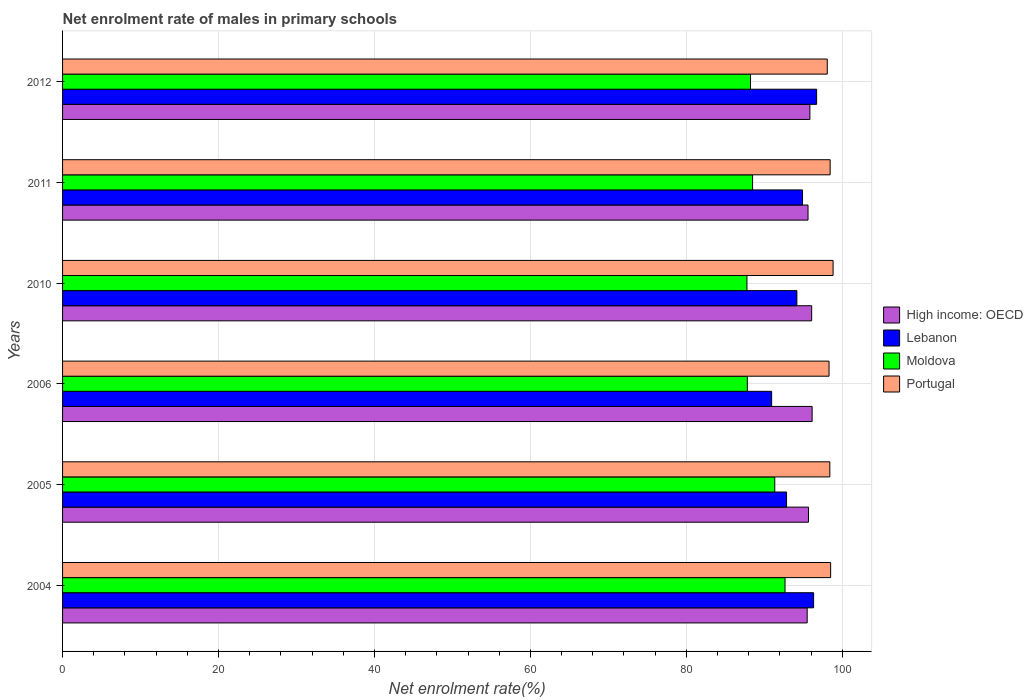How many different coloured bars are there?
Keep it short and to the point. 4. How many groups of bars are there?
Your answer should be very brief. 6. Are the number of bars per tick equal to the number of legend labels?
Provide a succinct answer. Yes. How many bars are there on the 2nd tick from the top?
Keep it short and to the point. 4. How many bars are there on the 5th tick from the bottom?
Your answer should be very brief. 4. What is the label of the 5th group of bars from the top?
Your answer should be compact. 2005. In how many cases, is the number of bars for a given year not equal to the number of legend labels?
Offer a terse response. 0. What is the net enrolment rate of males in primary schools in Moldova in 2012?
Offer a terse response. 88.23. Across all years, what is the maximum net enrolment rate of males in primary schools in High income: OECD?
Make the answer very short. 96.13. Across all years, what is the minimum net enrolment rate of males in primary schools in High income: OECD?
Your answer should be very brief. 95.5. In which year was the net enrolment rate of males in primary schools in Portugal maximum?
Keep it short and to the point. 2010. In which year was the net enrolment rate of males in primary schools in Portugal minimum?
Provide a short and direct response. 2012. What is the total net enrolment rate of males in primary schools in Lebanon in the graph?
Your answer should be very brief. 565.9. What is the difference between the net enrolment rate of males in primary schools in Lebanon in 2006 and that in 2010?
Your answer should be compact. -3.24. What is the difference between the net enrolment rate of males in primary schools in Portugal in 2004 and the net enrolment rate of males in primary schools in High income: OECD in 2005?
Keep it short and to the point. 2.84. What is the average net enrolment rate of males in primary schools in Lebanon per year?
Keep it short and to the point. 94.32. In the year 2005, what is the difference between the net enrolment rate of males in primary schools in Lebanon and net enrolment rate of males in primary schools in High income: OECD?
Make the answer very short. -2.81. What is the ratio of the net enrolment rate of males in primary schools in Moldova in 2004 to that in 2006?
Keep it short and to the point. 1.06. Is the difference between the net enrolment rate of males in primary schools in Lebanon in 2006 and 2011 greater than the difference between the net enrolment rate of males in primary schools in High income: OECD in 2006 and 2011?
Provide a succinct answer. No. What is the difference between the highest and the second highest net enrolment rate of males in primary schools in High income: OECD?
Ensure brevity in your answer.  0.06. What is the difference between the highest and the lowest net enrolment rate of males in primary schools in Lebanon?
Keep it short and to the point. 5.77. What does the 2nd bar from the bottom in 2006 represents?
Your response must be concise. Lebanon. Is it the case that in every year, the sum of the net enrolment rate of males in primary schools in Portugal and net enrolment rate of males in primary schools in Moldova is greater than the net enrolment rate of males in primary schools in High income: OECD?
Ensure brevity in your answer.  Yes. What is the difference between two consecutive major ticks on the X-axis?
Provide a succinct answer. 20. Where does the legend appear in the graph?
Your answer should be very brief. Center right. How many legend labels are there?
Keep it short and to the point. 4. What is the title of the graph?
Provide a short and direct response. Net enrolment rate of males in primary schools. What is the label or title of the X-axis?
Ensure brevity in your answer.  Net enrolment rate(%). What is the Net enrolment rate(%) in High income: OECD in 2004?
Offer a very short reply. 95.5. What is the Net enrolment rate(%) of Lebanon in 2004?
Your answer should be very brief. 96.32. What is the Net enrolment rate(%) of Moldova in 2004?
Keep it short and to the point. 92.66. What is the Net enrolment rate(%) of Portugal in 2004?
Provide a short and direct response. 98.51. What is the Net enrolment rate(%) in High income: OECD in 2005?
Your answer should be very brief. 95.67. What is the Net enrolment rate(%) of Lebanon in 2005?
Offer a very short reply. 92.85. What is the Net enrolment rate(%) in Moldova in 2005?
Provide a succinct answer. 91.34. What is the Net enrolment rate(%) of Portugal in 2005?
Your answer should be very brief. 98.4. What is the Net enrolment rate(%) in High income: OECD in 2006?
Keep it short and to the point. 96.13. What is the Net enrolment rate(%) in Lebanon in 2006?
Provide a short and direct response. 90.94. What is the Net enrolment rate(%) of Moldova in 2006?
Your answer should be compact. 87.82. What is the Net enrolment rate(%) of Portugal in 2006?
Make the answer very short. 98.3. What is the Net enrolment rate(%) of High income: OECD in 2010?
Keep it short and to the point. 96.08. What is the Net enrolment rate(%) of Lebanon in 2010?
Offer a terse response. 94.18. What is the Net enrolment rate(%) of Moldova in 2010?
Ensure brevity in your answer.  87.77. What is the Net enrolment rate(%) in Portugal in 2010?
Your answer should be compact. 98.82. What is the Net enrolment rate(%) of High income: OECD in 2011?
Offer a very short reply. 95.61. What is the Net enrolment rate(%) of Lebanon in 2011?
Make the answer very short. 94.9. What is the Net enrolment rate(%) of Moldova in 2011?
Your answer should be very brief. 88.49. What is the Net enrolment rate(%) of Portugal in 2011?
Your answer should be compact. 98.44. What is the Net enrolment rate(%) of High income: OECD in 2012?
Offer a terse response. 95.85. What is the Net enrolment rate(%) of Lebanon in 2012?
Provide a short and direct response. 96.71. What is the Net enrolment rate(%) of Moldova in 2012?
Your answer should be compact. 88.23. What is the Net enrolment rate(%) of Portugal in 2012?
Your answer should be very brief. 98.07. Across all years, what is the maximum Net enrolment rate(%) in High income: OECD?
Your response must be concise. 96.13. Across all years, what is the maximum Net enrolment rate(%) of Lebanon?
Give a very brief answer. 96.71. Across all years, what is the maximum Net enrolment rate(%) in Moldova?
Your response must be concise. 92.66. Across all years, what is the maximum Net enrolment rate(%) in Portugal?
Offer a terse response. 98.82. Across all years, what is the minimum Net enrolment rate(%) in High income: OECD?
Keep it short and to the point. 95.5. Across all years, what is the minimum Net enrolment rate(%) of Lebanon?
Your answer should be compact. 90.94. Across all years, what is the minimum Net enrolment rate(%) in Moldova?
Your response must be concise. 87.77. Across all years, what is the minimum Net enrolment rate(%) of Portugal?
Provide a short and direct response. 98.07. What is the total Net enrolment rate(%) in High income: OECD in the graph?
Keep it short and to the point. 574.83. What is the total Net enrolment rate(%) of Lebanon in the graph?
Your response must be concise. 565.9. What is the total Net enrolment rate(%) of Moldova in the graph?
Offer a very short reply. 536.32. What is the total Net enrolment rate(%) of Portugal in the graph?
Make the answer very short. 590.55. What is the difference between the Net enrolment rate(%) of High income: OECD in 2004 and that in 2005?
Ensure brevity in your answer.  -0.17. What is the difference between the Net enrolment rate(%) of Lebanon in 2004 and that in 2005?
Your answer should be very brief. 3.47. What is the difference between the Net enrolment rate(%) of Moldova in 2004 and that in 2005?
Offer a very short reply. 1.32. What is the difference between the Net enrolment rate(%) in Portugal in 2004 and that in 2005?
Your answer should be compact. 0.11. What is the difference between the Net enrolment rate(%) in High income: OECD in 2004 and that in 2006?
Offer a very short reply. -0.63. What is the difference between the Net enrolment rate(%) of Lebanon in 2004 and that in 2006?
Ensure brevity in your answer.  5.38. What is the difference between the Net enrolment rate(%) in Moldova in 2004 and that in 2006?
Make the answer very short. 4.84. What is the difference between the Net enrolment rate(%) in Portugal in 2004 and that in 2006?
Ensure brevity in your answer.  0.2. What is the difference between the Net enrolment rate(%) of High income: OECD in 2004 and that in 2010?
Make the answer very short. -0.58. What is the difference between the Net enrolment rate(%) of Lebanon in 2004 and that in 2010?
Your answer should be very brief. 2.14. What is the difference between the Net enrolment rate(%) of Moldova in 2004 and that in 2010?
Your answer should be very brief. 4.89. What is the difference between the Net enrolment rate(%) in Portugal in 2004 and that in 2010?
Keep it short and to the point. -0.31. What is the difference between the Net enrolment rate(%) of High income: OECD in 2004 and that in 2011?
Your answer should be compact. -0.11. What is the difference between the Net enrolment rate(%) in Lebanon in 2004 and that in 2011?
Provide a short and direct response. 1.42. What is the difference between the Net enrolment rate(%) of Moldova in 2004 and that in 2011?
Provide a short and direct response. 4.16. What is the difference between the Net enrolment rate(%) of Portugal in 2004 and that in 2011?
Provide a succinct answer. 0.06. What is the difference between the Net enrolment rate(%) of High income: OECD in 2004 and that in 2012?
Keep it short and to the point. -0.35. What is the difference between the Net enrolment rate(%) in Lebanon in 2004 and that in 2012?
Provide a short and direct response. -0.39. What is the difference between the Net enrolment rate(%) in Moldova in 2004 and that in 2012?
Give a very brief answer. 4.43. What is the difference between the Net enrolment rate(%) in Portugal in 2004 and that in 2012?
Give a very brief answer. 0.43. What is the difference between the Net enrolment rate(%) of High income: OECD in 2005 and that in 2006?
Your answer should be very brief. -0.47. What is the difference between the Net enrolment rate(%) of Lebanon in 2005 and that in 2006?
Ensure brevity in your answer.  1.91. What is the difference between the Net enrolment rate(%) in Moldova in 2005 and that in 2006?
Give a very brief answer. 3.52. What is the difference between the Net enrolment rate(%) of Portugal in 2005 and that in 2006?
Keep it short and to the point. 0.1. What is the difference between the Net enrolment rate(%) of High income: OECD in 2005 and that in 2010?
Provide a short and direct response. -0.41. What is the difference between the Net enrolment rate(%) in Lebanon in 2005 and that in 2010?
Your response must be concise. -1.32. What is the difference between the Net enrolment rate(%) in Moldova in 2005 and that in 2010?
Provide a short and direct response. 3.57. What is the difference between the Net enrolment rate(%) of Portugal in 2005 and that in 2010?
Ensure brevity in your answer.  -0.42. What is the difference between the Net enrolment rate(%) in High income: OECD in 2005 and that in 2011?
Offer a very short reply. 0.06. What is the difference between the Net enrolment rate(%) in Lebanon in 2005 and that in 2011?
Your answer should be very brief. -2.05. What is the difference between the Net enrolment rate(%) in Moldova in 2005 and that in 2011?
Your answer should be compact. 2.85. What is the difference between the Net enrolment rate(%) of Portugal in 2005 and that in 2011?
Give a very brief answer. -0.04. What is the difference between the Net enrolment rate(%) of High income: OECD in 2005 and that in 2012?
Give a very brief answer. -0.18. What is the difference between the Net enrolment rate(%) of Lebanon in 2005 and that in 2012?
Provide a succinct answer. -3.86. What is the difference between the Net enrolment rate(%) of Moldova in 2005 and that in 2012?
Provide a succinct answer. 3.11. What is the difference between the Net enrolment rate(%) of Portugal in 2005 and that in 2012?
Provide a short and direct response. 0.33. What is the difference between the Net enrolment rate(%) in High income: OECD in 2006 and that in 2010?
Give a very brief answer. 0.06. What is the difference between the Net enrolment rate(%) in Lebanon in 2006 and that in 2010?
Your answer should be compact. -3.24. What is the difference between the Net enrolment rate(%) in Moldova in 2006 and that in 2010?
Provide a short and direct response. 0.05. What is the difference between the Net enrolment rate(%) in Portugal in 2006 and that in 2010?
Ensure brevity in your answer.  -0.52. What is the difference between the Net enrolment rate(%) in High income: OECD in 2006 and that in 2011?
Your answer should be compact. 0.53. What is the difference between the Net enrolment rate(%) in Lebanon in 2006 and that in 2011?
Make the answer very short. -3.96. What is the difference between the Net enrolment rate(%) of Moldova in 2006 and that in 2011?
Give a very brief answer. -0.67. What is the difference between the Net enrolment rate(%) in Portugal in 2006 and that in 2011?
Your response must be concise. -0.14. What is the difference between the Net enrolment rate(%) of High income: OECD in 2006 and that in 2012?
Give a very brief answer. 0.29. What is the difference between the Net enrolment rate(%) in Lebanon in 2006 and that in 2012?
Provide a succinct answer. -5.77. What is the difference between the Net enrolment rate(%) of Moldova in 2006 and that in 2012?
Keep it short and to the point. -0.41. What is the difference between the Net enrolment rate(%) of Portugal in 2006 and that in 2012?
Provide a short and direct response. 0.23. What is the difference between the Net enrolment rate(%) in High income: OECD in 2010 and that in 2011?
Give a very brief answer. 0.47. What is the difference between the Net enrolment rate(%) in Lebanon in 2010 and that in 2011?
Offer a very short reply. -0.73. What is the difference between the Net enrolment rate(%) of Moldova in 2010 and that in 2011?
Provide a succinct answer. -0.72. What is the difference between the Net enrolment rate(%) in Portugal in 2010 and that in 2011?
Your answer should be compact. 0.38. What is the difference between the Net enrolment rate(%) of High income: OECD in 2010 and that in 2012?
Make the answer very short. 0.23. What is the difference between the Net enrolment rate(%) in Lebanon in 2010 and that in 2012?
Your answer should be compact. -2.53. What is the difference between the Net enrolment rate(%) of Moldova in 2010 and that in 2012?
Offer a very short reply. -0.46. What is the difference between the Net enrolment rate(%) of Portugal in 2010 and that in 2012?
Your answer should be compact. 0.75. What is the difference between the Net enrolment rate(%) in High income: OECD in 2011 and that in 2012?
Provide a succinct answer. -0.24. What is the difference between the Net enrolment rate(%) of Lebanon in 2011 and that in 2012?
Your answer should be very brief. -1.81. What is the difference between the Net enrolment rate(%) of Moldova in 2011 and that in 2012?
Make the answer very short. 0.26. What is the difference between the Net enrolment rate(%) of Portugal in 2011 and that in 2012?
Give a very brief answer. 0.37. What is the difference between the Net enrolment rate(%) of High income: OECD in 2004 and the Net enrolment rate(%) of Lebanon in 2005?
Keep it short and to the point. 2.65. What is the difference between the Net enrolment rate(%) in High income: OECD in 2004 and the Net enrolment rate(%) in Moldova in 2005?
Keep it short and to the point. 4.16. What is the difference between the Net enrolment rate(%) of High income: OECD in 2004 and the Net enrolment rate(%) of Portugal in 2005?
Provide a succinct answer. -2.9. What is the difference between the Net enrolment rate(%) in Lebanon in 2004 and the Net enrolment rate(%) in Moldova in 2005?
Ensure brevity in your answer.  4.98. What is the difference between the Net enrolment rate(%) in Lebanon in 2004 and the Net enrolment rate(%) in Portugal in 2005?
Keep it short and to the point. -2.08. What is the difference between the Net enrolment rate(%) of Moldova in 2004 and the Net enrolment rate(%) of Portugal in 2005?
Your response must be concise. -5.75. What is the difference between the Net enrolment rate(%) in High income: OECD in 2004 and the Net enrolment rate(%) in Lebanon in 2006?
Give a very brief answer. 4.56. What is the difference between the Net enrolment rate(%) in High income: OECD in 2004 and the Net enrolment rate(%) in Moldova in 2006?
Your response must be concise. 7.68. What is the difference between the Net enrolment rate(%) of High income: OECD in 2004 and the Net enrolment rate(%) of Portugal in 2006?
Your response must be concise. -2.8. What is the difference between the Net enrolment rate(%) in Lebanon in 2004 and the Net enrolment rate(%) in Moldova in 2006?
Keep it short and to the point. 8.5. What is the difference between the Net enrolment rate(%) in Lebanon in 2004 and the Net enrolment rate(%) in Portugal in 2006?
Make the answer very short. -1.98. What is the difference between the Net enrolment rate(%) in Moldova in 2004 and the Net enrolment rate(%) in Portugal in 2006?
Offer a very short reply. -5.65. What is the difference between the Net enrolment rate(%) of High income: OECD in 2004 and the Net enrolment rate(%) of Lebanon in 2010?
Provide a short and direct response. 1.32. What is the difference between the Net enrolment rate(%) in High income: OECD in 2004 and the Net enrolment rate(%) in Moldova in 2010?
Your answer should be very brief. 7.73. What is the difference between the Net enrolment rate(%) of High income: OECD in 2004 and the Net enrolment rate(%) of Portugal in 2010?
Provide a succinct answer. -3.32. What is the difference between the Net enrolment rate(%) in Lebanon in 2004 and the Net enrolment rate(%) in Moldova in 2010?
Your answer should be very brief. 8.55. What is the difference between the Net enrolment rate(%) of Lebanon in 2004 and the Net enrolment rate(%) of Portugal in 2010?
Make the answer very short. -2.5. What is the difference between the Net enrolment rate(%) of Moldova in 2004 and the Net enrolment rate(%) of Portugal in 2010?
Offer a very short reply. -6.16. What is the difference between the Net enrolment rate(%) in High income: OECD in 2004 and the Net enrolment rate(%) in Lebanon in 2011?
Provide a succinct answer. 0.6. What is the difference between the Net enrolment rate(%) of High income: OECD in 2004 and the Net enrolment rate(%) of Moldova in 2011?
Give a very brief answer. 7. What is the difference between the Net enrolment rate(%) in High income: OECD in 2004 and the Net enrolment rate(%) in Portugal in 2011?
Make the answer very short. -2.95. What is the difference between the Net enrolment rate(%) of Lebanon in 2004 and the Net enrolment rate(%) of Moldova in 2011?
Keep it short and to the point. 7.83. What is the difference between the Net enrolment rate(%) in Lebanon in 2004 and the Net enrolment rate(%) in Portugal in 2011?
Make the answer very short. -2.12. What is the difference between the Net enrolment rate(%) of Moldova in 2004 and the Net enrolment rate(%) of Portugal in 2011?
Offer a very short reply. -5.79. What is the difference between the Net enrolment rate(%) in High income: OECD in 2004 and the Net enrolment rate(%) in Lebanon in 2012?
Your answer should be compact. -1.21. What is the difference between the Net enrolment rate(%) in High income: OECD in 2004 and the Net enrolment rate(%) in Moldova in 2012?
Offer a very short reply. 7.27. What is the difference between the Net enrolment rate(%) in High income: OECD in 2004 and the Net enrolment rate(%) in Portugal in 2012?
Keep it short and to the point. -2.58. What is the difference between the Net enrolment rate(%) of Lebanon in 2004 and the Net enrolment rate(%) of Moldova in 2012?
Offer a very short reply. 8.09. What is the difference between the Net enrolment rate(%) in Lebanon in 2004 and the Net enrolment rate(%) in Portugal in 2012?
Keep it short and to the point. -1.75. What is the difference between the Net enrolment rate(%) in Moldova in 2004 and the Net enrolment rate(%) in Portugal in 2012?
Give a very brief answer. -5.42. What is the difference between the Net enrolment rate(%) in High income: OECD in 2005 and the Net enrolment rate(%) in Lebanon in 2006?
Make the answer very short. 4.73. What is the difference between the Net enrolment rate(%) of High income: OECD in 2005 and the Net enrolment rate(%) of Moldova in 2006?
Provide a short and direct response. 7.84. What is the difference between the Net enrolment rate(%) of High income: OECD in 2005 and the Net enrolment rate(%) of Portugal in 2006?
Offer a very short reply. -2.64. What is the difference between the Net enrolment rate(%) in Lebanon in 2005 and the Net enrolment rate(%) in Moldova in 2006?
Offer a terse response. 5.03. What is the difference between the Net enrolment rate(%) of Lebanon in 2005 and the Net enrolment rate(%) of Portugal in 2006?
Offer a terse response. -5.45. What is the difference between the Net enrolment rate(%) in Moldova in 2005 and the Net enrolment rate(%) in Portugal in 2006?
Offer a very short reply. -6.96. What is the difference between the Net enrolment rate(%) in High income: OECD in 2005 and the Net enrolment rate(%) in Lebanon in 2010?
Your answer should be compact. 1.49. What is the difference between the Net enrolment rate(%) of High income: OECD in 2005 and the Net enrolment rate(%) of Moldova in 2010?
Provide a succinct answer. 7.89. What is the difference between the Net enrolment rate(%) in High income: OECD in 2005 and the Net enrolment rate(%) in Portugal in 2010?
Offer a very short reply. -3.15. What is the difference between the Net enrolment rate(%) of Lebanon in 2005 and the Net enrolment rate(%) of Moldova in 2010?
Offer a very short reply. 5.08. What is the difference between the Net enrolment rate(%) of Lebanon in 2005 and the Net enrolment rate(%) of Portugal in 2010?
Your response must be concise. -5.97. What is the difference between the Net enrolment rate(%) in Moldova in 2005 and the Net enrolment rate(%) in Portugal in 2010?
Make the answer very short. -7.48. What is the difference between the Net enrolment rate(%) of High income: OECD in 2005 and the Net enrolment rate(%) of Lebanon in 2011?
Provide a succinct answer. 0.76. What is the difference between the Net enrolment rate(%) in High income: OECD in 2005 and the Net enrolment rate(%) in Moldova in 2011?
Offer a very short reply. 7.17. What is the difference between the Net enrolment rate(%) of High income: OECD in 2005 and the Net enrolment rate(%) of Portugal in 2011?
Offer a terse response. -2.78. What is the difference between the Net enrolment rate(%) in Lebanon in 2005 and the Net enrolment rate(%) in Moldova in 2011?
Keep it short and to the point. 4.36. What is the difference between the Net enrolment rate(%) in Lebanon in 2005 and the Net enrolment rate(%) in Portugal in 2011?
Ensure brevity in your answer.  -5.59. What is the difference between the Net enrolment rate(%) in Moldova in 2005 and the Net enrolment rate(%) in Portugal in 2011?
Offer a very short reply. -7.1. What is the difference between the Net enrolment rate(%) in High income: OECD in 2005 and the Net enrolment rate(%) in Lebanon in 2012?
Give a very brief answer. -1.04. What is the difference between the Net enrolment rate(%) of High income: OECD in 2005 and the Net enrolment rate(%) of Moldova in 2012?
Your answer should be compact. 7.44. What is the difference between the Net enrolment rate(%) of High income: OECD in 2005 and the Net enrolment rate(%) of Portugal in 2012?
Provide a short and direct response. -2.41. What is the difference between the Net enrolment rate(%) in Lebanon in 2005 and the Net enrolment rate(%) in Moldova in 2012?
Offer a terse response. 4.62. What is the difference between the Net enrolment rate(%) of Lebanon in 2005 and the Net enrolment rate(%) of Portugal in 2012?
Provide a succinct answer. -5.22. What is the difference between the Net enrolment rate(%) of Moldova in 2005 and the Net enrolment rate(%) of Portugal in 2012?
Provide a succinct answer. -6.73. What is the difference between the Net enrolment rate(%) of High income: OECD in 2006 and the Net enrolment rate(%) of Lebanon in 2010?
Offer a very short reply. 1.96. What is the difference between the Net enrolment rate(%) in High income: OECD in 2006 and the Net enrolment rate(%) in Moldova in 2010?
Make the answer very short. 8.36. What is the difference between the Net enrolment rate(%) in High income: OECD in 2006 and the Net enrolment rate(%) in Portugal in 2010?
Provide a short and direct response. -2.69. What is the difference between the Net enrolment rate(%) of Lebanon in 2006 and the Net enrolment rate(%) of Moldova in 2010?
Provide a succinct answer. 3.17. What is the difference between the Net enrolment rate(%) in Lebanon in 2006 and the Net enrolment rate(%) in Portugal in 2010?
Ensure brevity in your answer.  -7.88. What is the difference between the Net enrolment rate(%) of Moldova in 2006 and the Net enrolment rate(%) of Portugal in 2010?
Make the answer very short. -11. What is the difference between the Net enrolment rate(%) in High income: OECD in 2006 and the Net enrolment rate(%) in Lebanon in 2011?
Offer a terse response. 1.23. What is the difference between the Net enrolment rate(%) in High income: OECD in 2006 and the Net enrolment rate(%) in Moldova in 2011?
Your answer should be very brief. 7.64. What is the difference between the Net enrolment rate(%) in High income: OECD in 2006 and the Net enrolment rate(%) in Portugal in 2011?
Your answer should be very brief. -2.31. What is the difference between the Net enrolment rate(%) in Lebanon in 2006 and the Net enrolment rate(%) in Moldova in 2011?
Make the answer very short. 2.44. What is the difference between the Net enrolment rate(%) in Lebanon in 2006 and the Net enrolment rate(%) in Portugal in 2011?
Your answer should be compact. -7.5. What is the difference between the Net enrolment rate(%) in Moldova in 2006 and the Net enrolment rate(%) in Portugal in 2011?
Your answer should be compact. -10.62. What is the difference between the Net enrolment rate(%) of High income: OECD in 2006 and the Net enrolment rate(%) of Lebanon in 2012?
Offer a very short reply. -0.57. What is the difference between the Net enrolment rate(%) of High income: OECD in 2006 and the Net enrolment rate(%) of Moldova in 2012?
Your answer should be very brief. 7.9. What is the difference between the Net enrolment rate(%) in High income: OECD in 2006 and the Net enrolment rate(%) in Portugal in 2012?
Your answer should be compact. -1.94. What is the difference between the Net enrolment rate(%) of Lebanon in 2006 and the Net enrolment rate(%) of Moldova in 2012?
Your response must be concise. 2.71. What is the difference between the Net enrolment rate(%) of Lebanon in 2006 and the Net enrolment rate(%) of Portugal in 2012?
Your answer should be compact. -7.13. What is the difference between the Net enrolment rate(%) of Moldova in 2006 and the Net enrolment rate(%) of Portugal in 2012?
Provide a short and direct response. -10.25. What is the difference between the Net enrolment rate(%) of High income: OECD in 2010 and the Net enrolment rate(%) of Lebanon in 2011?
Your response must be concise. 1.17. What is the difference between the Net enrolment rate(%) in High income: OECD in 2010 and the Net enrolment rate(%) in Moldova in 2011?
Provide a succinct answer. 7.58. What is the difference between the Net enrolment rate(%) of High income: OECD in 2010 and the Net enrolment rate(%) of Portugal in 2011?
Give a very brief answer. -2.37. What is the difference between the Net enrolment rate(%) in Lebanon in 2010 and the Net enrolment rate(%) in Moldova in 2011?
Your answer should be very brief. 5.68. What is the difference between the Net enrolment rate(%) of Lebanon in 2010 and the Net enrolment rate(%) of Portugal in 2011?
Provide a succinct answer. -4.27. What is the difference between the Net enrolment rate(%) of Moldova in 2010 and the Net enrolment rate(%) of Portugal in 2011?
Keep it short and to the point. -10.67. What is the difference between the Net enrolment rate(%) in High income: OECD in 2010 and the Net enrolment rate(%) in Lebanon in 2012?
Provide a short and direct response. -0.63. What is the difference between the Net enrolment rate(%) in High income: OECD in 2010 and the Net enrolment rate(%) in Moldova in 2012?
Make the answer very short. 7.84. What is the difference between the Net enrolment rate(%) in High income: OECD in 2010 and the Net enrolment rate(%) in Portugal in 2012?
Offer a terse response. -2. What is the difference between the Net enrolment rate(%) of Lebanon in 2010 and the Net enrolment rate(%) of Moldova in 2012?
Your response must be concise. 5.95. What is the difference between the Net enrolment rate(%) of Lebanon in 2010 and the Net enrolment rate(%) of Portugal in 2012?
Your answer should be compact. -3.9. What is the difference between the Net enrolment rate(%) in Moldova in 2010 and the Net enrolment rate(%) in Portugal in 2012?
Offer a terse response. -10.3. What is the difference between the Net enrolment rate(%) in High income: OECD in 2011 and the Net enrolment rate(%) in Lebanon in 2012?
Provide a short and direct response. -1.1. What is the difference between the Net enrolment rate(%) of High income: OECD in 2011 and the Net enrolment rate(%) of Moldova in 2012?
Offer a terse response. 7.38. What is the difference between the Net enrolment rate(%) in High income: OECD in 2011 and the Net enrolment rate(%) in Portugal in 2012?
Offer a very short reply. -2.47. What is the difference between the Net enrolment rate(%) in Lebanon in 2011 and the Net enrolment rate(%) in Moldova in 2012?
Offer a very short reply. 6.67. What is the difference between the Net enrolment rate(%) in Lebanon in 2011 and the Net enrolment rate(%) in Portugal in 2012?
Keep it short and to the point. -3.17. What is the difference between the Net enrolment rate(%) in Moldova in 2011 and the Net enrolment rate(%) in Portugal in 2012?
Give a very brief answer. -9.58. What is the average Net enrolment rate(%) in High income: OECD per year?
Your answer should be very brief. 95.8. What is the average Net enrolment rate(%) of Lebanon per year?
Make the answer very short. 94.32. What is the average Net enrolment rate(%) in Moldova per year?
Your response must be concise. 89.39. What is the average Net enrolment rate(%) of Portugal per year?
Your answer should be very brief. 98.43. In the year 2004, what is the difference between the Net enrolment rate(%) of High income: OECD and Net enrolment rate(%) of Lebanon?
Provide a succinct answer. -0.82. In the year 2004, what is the difference between the Net enrolment rate(%) of High income: OECD and Net enrolment rate(%) of Moldova?
Your answer should be compact. 2.84. In the year 2004, what is the difference between the Net enrolment rate(%) in High income: OECD and Net enrolment rate(%) in Portugal?
Offer a very short reply. -3.01. In the year 2004, what is the difference between the Net enrolment rate(%) of Lebanon and Net enrolment rate(%) of Moldova?
Make the answer very short. 3.66. In the year 2004, what is the difference between the Net enrolment rate(%) in Lebanon and Net enrolment rate(%) in Portugal?
Your answer should be very brief. -2.19. In the year 2004, what is the difference between the Net enrolment rate(%) in Moldova and Net enrolment rate(%) in Portugal?
Your response must be concise. -5.85. In the year 2005, what is the difference between the Net enrolment rate(%) of High income: OECD and Net enrolment rate(%) of Lebanon?
Make the answer very short. 2.81. In the year 2005, what is the difference between the Net enrolment rate(%) of High income: OECD and Net enrolment rate(%) of Moldova?
Your answer should be very brief. 4.33. In the year 2005, what is the difference between the Net enrolment rate(%) in High income: OECD and Net enrolment rate(%) in Portugal?
Give a very brief answer. -2.74. In the year 2005, what is the difference between the Net enrolment rate(%) of Lebanon and Net enrolment rate(%) of Moldova?
Ensure brevity in your answer.  1.51. In the year 2005, what is the difference between the Net enrolment rate(%) of Lebanon and Net enrolment rate(%) of Portugal?
Your response must be concise. -5.55. In the year 2005, what is the difference between the Net enrolment rate(%) in Moldova and Net enrolment rate(%) in Portugal?
Keep it short and to the point. -7.06. In the year 2006, what is the difference between the Net enrolment rate(%) of High income: OECD and Net enrolment rate(%) of Lebanon?
Ensure brevity in your answer.  5.19. In the year 2006, what is the difference between the Net enrolment rate(%) in High income: OECD and Net enrolment rate(%) in Moldova?
Your answer should be compact. 8.31. In the year 2006, what is the difference between the Net enrolment rate(%) in High income: OECD and Net enrolment rate(%) in Portugal?
Offer a terse response. -2.17. In the year 2006, what is the difference between the Net enrolment rate(%) of Lebanon and Net enrolment rate(%) of Moldova?
Provide a succinct answer. 3.12. In the year 2006, what is the difference between the Net enrolment rate(%) in Lebanon and Net enrolment rate(%) in Portugal?
Give a very brief answer. -7.36. In the year 2006, what is the difference between the Net enrolment rate(%) of Moldova and Net enrolment rate(%) of Portugal?
Ensure brevity in your answer.  -10.48. In the year 2010, what is the difference between the Net enrolment rate(%) in High income: OECD and Net enrolment rate(%) in Lebanon?
Your answer should be compact. 1.9. In the year 2010, what is the difference between the Net enrolment rate(%) in High income: OECD and Net enrolment rate(%) in Moldova?
Give a very brief answer. 8.3. In the year 2010, what is the difference between the Net enrolment rate(%) in High income: OECD and Net enrolment rate(%) in Portugal?
Offer a very short reply. -2.74. In the year 2010, what is the difference between the Net enrolment rate(%) in Lebanon and Net enrolment rate(%) in Moldova?
Your answer should be very brief. 6.41. In the year 2010, what is the difference between the Net enrolment rate(%) of Lebanon and Net enrolment rate(%) of Portugal?
Make the answer very short. -4.64. In the year 2010, what is the difference between the Net enrolment rate(%) of Moldova and Net enrolment rate(%) of Portugal?
Your answer should be compact. -11.05. In the year 2011, what is the difference between the Net enrolment rate(%) in High income: OECD and Net enrolment rate(%) in Lebanon?
Your answer should be very brief. 0.71. In the year 2011, what is the difference between the Net enrolment rate(%) in High income: OECD and Net enrolment rate(%) in Moldova?
Your answer should be compact. 7.11. In the year 2011, what is the difference between the Net enrolment rate(%) in High income: OECD and Net enrolment rate(%) in Portugal?
Your answer should be very brief. -2.84. In the year 2011, what is the difference between the Net enrolment rate(%) in Lebanon and Net enrolment rate(%) in Moldova?
Offer a very short reply. 6.41. In the year 2011, what is the difference between the Net enrolment rate(%) in Lebanon and Net enrolment rate(%) in Portugal?
Keep it short and to the point. -3.54. In the year 2011, what is the difference between the Net enrolment rate(%) of Moldova and Net enrolment rate(%) of Portugal?
Ensure brevity in your answer.  -9.95. In the year 2012, what is the difference between the Net enrolment rate(%) in High income: OECD and Net enrolment rate(%) in Lebanon?
Give a very brief answer. -0.86. In the year 2012, what is the difference between the Net enrolment rate(%) of High income: OECD and Net enrolment rate(%) of Moldova?
Provide a short and direct response. 7.62. In the year 2012, what is the difference between the Net enrolment rate(%) in High income: OECD and Net enrolment rate(%) in Portugal?
Provide a succinct answer. -2.23. In the year 2012, what is the difference between the Net enrolment rate(%) of Lebanon and Net enrolment rate(%) of Moldova?
Your answer should be very brief. 8.48. In the year 2012, what is the difference between the Net enrolment rate(%) of Lebanon and Net enrolment rate(%) of Portugal?
Your answer should be compact. -1.37. In the year 2012, what is the difference between the Net enrolment rate(%) of Moldova and Net enrolment rate(%) of Portugal?
Offer a terse response. -9.84. What is the ratio of the Net enrolment rate(%) in High income: OECD in 2004 to that in 2005?
Provide a succinct answer. 1. What is the ratio of the Net enrolment rate(%) in Lebanon in 2004 to that in 2005?
Give a very brief answer. 1.04. What is the ratio of the Net enrolment rate(%) of Moldova in 2004 to that in 2005?
Make the answer very short. 1.01. What is the ratio of the Net enrolment rate(%) of High income: OECD in 2004 to that in 2006?
Keep it short and to the point. 0.99. What is the ratio of the Net enrolment rate(%) of Lebanon in 2004 to that in 2006?
Offer a terse response. 1.06. What is the ratio of the Net enrolment rate(%) of Moldova in 2004 to that in 2006?
Your answer should be compact. 1.06. What is the ratio of the Net enrolment rate(%) in Portugal in 2004 to that in 2006?
Offer a very short reply. 1. What is the ratio of the Net enrolment rate(%) of Lebanon in 2004 to that in 2010?
Your answer should be compact. 1.02. What is the ratio of the Net enrolment rate(%) of Moldova in 2004 to that in 2010?
Ensure brevity in your answer.  1.06. What is the ratio of the Net enrolment rate(%) of Portugal in 2004 to that in 2010?
Keep it short and to the point. 1. What is the ratio of the Net enrolment rate(%) in High income: OECD in 2004 to that in 2011?
Your response must be concise. 1. What is the ratio of the Net enrolment rate(%) in Lebanon in 2004 to that in 2011?
Give a very brief answer. 1.01. What is the ratio of the Net enrolment rate(%) in Moldova in 2004 to that in 2011?
Ensure brevity in your answer.  1.05. What is the ratio of the Net enrolment rate(%) of Portugal in 2004 to that in 2011?
Make the answer very short. 1. What is the ratio of the Net enrolment rate(%) of High income: OECD in 2004 to that in 2012?
Give a very brief answer. 1. What is the ratio of the Net enrolment rate(%) of Lebanon in 2004 to that in 2012?
Offer a terse response. 1. What is the ratio of the Net enrolment rate(%) of Moldova in 2004 to that in 2012?
Offer a very short reply. 1.05. What is the ratio of the Net enrolment rate(%) in High income: OECD in 2005 to that in 2006?
Keep it short and to the point. 1. What is the ratio of the Net enrolment rate(%) of Moldova in 2005 to that in 2006?
Provide a succinct answer. 1.04. What is the ratio of the Net enrolment rate(%) in Portugal in 2005 to that in 2006?
Your answer should be compact. 1. What is the ratio of the Net enrolment rate(%) of Lebanon in 2005 to that in 2010?
Give a very brief answer. 0.99. What is the ratio of the Net enrolment rate(%) of Moldova in 2005 to that in 2010?
Give a very brief answer. 1.04. What is the ratio of the Net enrolment rate(%) in Lebanon in 2005 to that in 2011?
Provide a short and direct response. 0.98. What is the ratio of the Net enrolment rate(%) of Moldova in 2005 to that in 2011?
Ensure brevity in your answer.  1.03. What is the ratio of the Net enrolment rate(%) in Portugal in 2005 to that in 2011?
Provide a short and direct response. 1. What is the ratio of the Net enrolment rate(%) of Lebanon in 2005 to that in 2012?
Keep it short and to the point. 0.96. What is the ratio of the Net enrolment rate(%) of Moldova in 2005 to that in 2012?
Your answer should be compact. 1.04. What is the ratio of the Net enrolment rate(%) in High income: OECD in 2006 to that in 2010?
Ensure brevity in your answer.  1. What is the ratio of the Net enrolment rate(%) in Lebanon in 2006 to that in 2010?
Make the answer very short. 0.97. What is the ratio of the Net enrolment rate(%) in Portugal in 2006 to that in 2010?
Ensure brevity in your answer.  0.99. What is the ratio of the Net enrolment rate(%) of High income: OECD in 2006 to that in 2011?
Offer a very short reply. 1.01. What is the ratio of the Net enrolment rate(%) of Lebanon in 2006 to that in 2011?
Make the answer very short. 0.96. What is the ratio of the Net enrolment rate(%) of Moldova in 2006 to that in 2011?
Provide a succinct answer. 0.99. What is the ratio of the Net enrolment rate(%) of Portugal in 2006 to that in 2011?
Ensure brevity in your answer.  1. What is the ratio of the Net enrolment rate(%) in High income: OECD in 2006 to that in 2012?
Keep it short and to the point. 1. What is the ratio of the Net enrolment rate(%) in Lebanon in 2006 to that in 2012?
Your answer should be compact. 0.94. What is the ratio of the Net enrolment rate(%) of Moldova in 2006 to that in 2012?
Your answer should be compact. 1. What is the ratio of the Net enrolment rate(%) of Portugal in 2006 to that in 2012?
Ensure brevity in your answer.  1. What is the ratio of the Net enrolment rate(%) of Lebanon in 2010 to that in 2011?
Provide a succinct answer. 0.99. What is the ratio of the Net enrolment rate(%) of Moldova in 2010 to that in 2011?
Give a very brief answer. 0.99. What is the ratio of the Net enrolment rate(%) of Lebanon in 2010 to that in 2012?
Your answer should be very brief. 0.97. What is the ratio of the Net enrolment rate(%) of Portugal in 2010 to that in 2012?
Keep it short and to the point. 1.01. What is the ratio of the Net enrolment rate(%) in High income: OECD in 2011 to that in 2012?
Provide a short and direct response. 1. What is the ratio of the Net enrolment rate(%) in Lebanon in 2011 to that in 2012?
Your answer should be very brief. 0.98. What is the ratio of the Net enrolment rate(%) of Portugal in 2011 to that in 2012?
Offer a very short reply. 1. What is the difference between the highest and the second highest Net enrolment rate(%) in High income: OECD?
Keep it short and to the point. 0.06. What is the difference between the highest and the second highest Net enrolment rate(%) in Lebanon?
Give a very brief answer. 0.39. What is the difference between the highest and the second highest Net enrolment rate(%) in Moldova?
Give a very brief answer. 1.32. What is the difference between the highest and the second highest Net enrolment rate(%) of Portugal?
Keep it short and to the point. 0.31. What is the difference between the highest and the lowest Net enrolment rate(%) in High income: OECD?
Offer a very short reply. 0.63. What is the difference between the highest and the lowest Net enrolment rate(%) of Lebanon?
Offer a terse response. 5.77. What is the difference between the highest and the lowest Net enrolment rate(%) of Moldova?
Offer a very short reply. 4.89. What is the difference between the highest and the lowest Net enrolment rate(%) in Portugal?
Your answer should be compact. 0.75. 